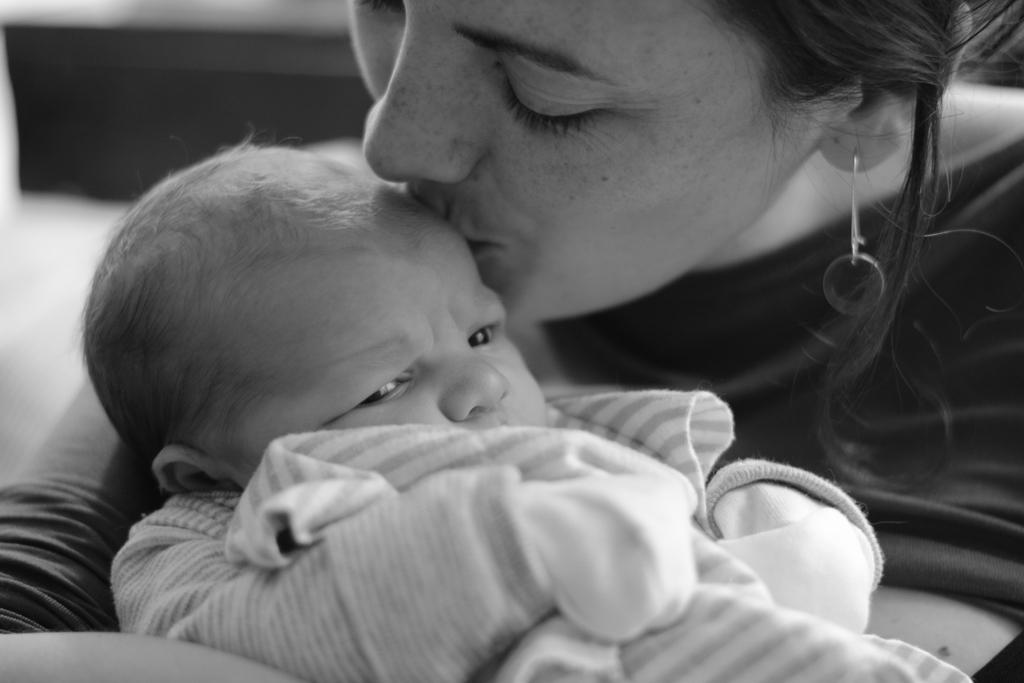Who is in the image? There is a woman in the image. What is the woman doing in the image? The woman is kissing a baby. Where is the shelf located in the image? There is no shelf present in the image. What type of cracker is the baby holding in the image? There is no cracker present in the image; the woman is kissing the baby. 